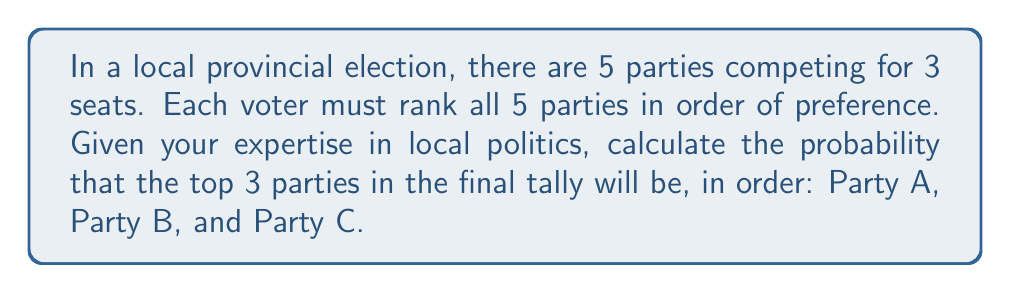Can you answer this question? Let's approach this step-by-step:

1) First, we need to understand what we're calculating. We're looking for the probability of a specific ordering of the top 3 parties out of 5.

2) This is a problem of permutations. We need to consider how many ways the 5 parties can be arranged, and then identify the favorable outcomes.

3) The total number of ways to arrange 5 parties is:

   $$5! = 5 \times 4 \times 3 \times 2 \times 1 = 120$$

4) Now, for our specific outcome, we need Party A to be first, Party B to be second, and Party C to be third. The other two parties can be in any order in the 4th and 5th positions.

5) The number of ways to arrange the remaining two parties is:

   $$2! = 2 \times 1 = 2$$

6) Therefore, there are 2 arrangements that satisfy our condition out of 120 total possible arrangements.

7) The probability is thus:

   $$P(\text{A, B, C in top 3 in order}) = \frac{\text{favorable outcomes}}{\text{total outcomes}} = \frac{2}{120} = \frac{1}{60}$$
Answer: $\frac{1}{60}$ 